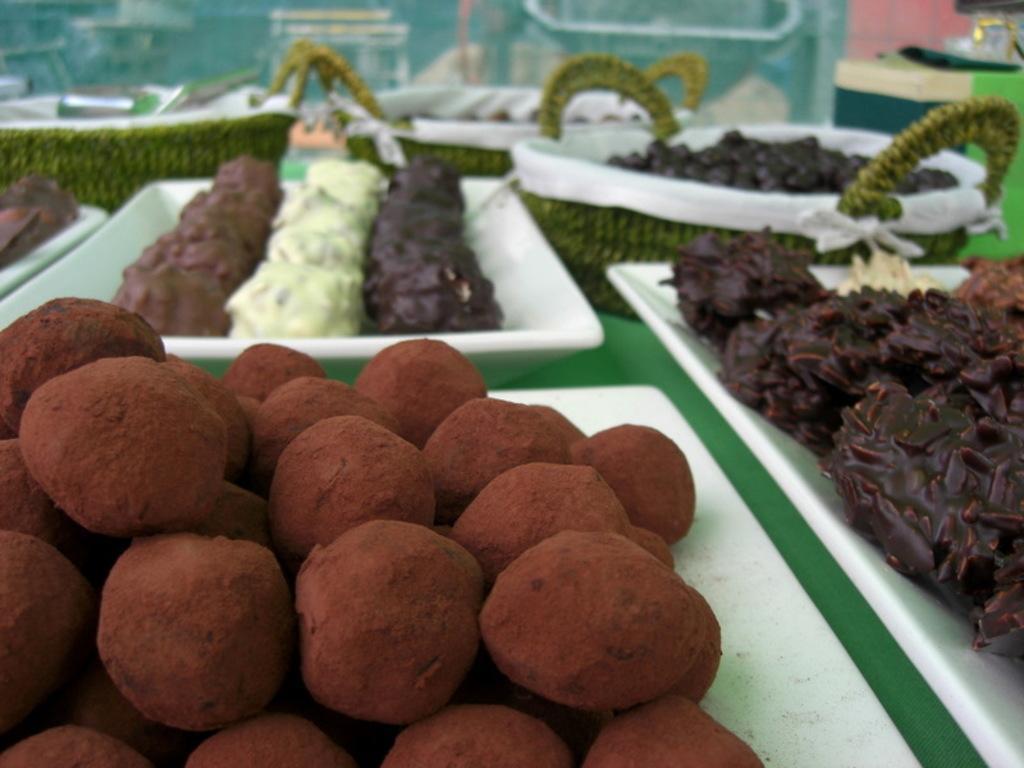Please provide a concise description of this image. In this image, we can see food items on the trays and baskets. In the background, there are some other objects. 